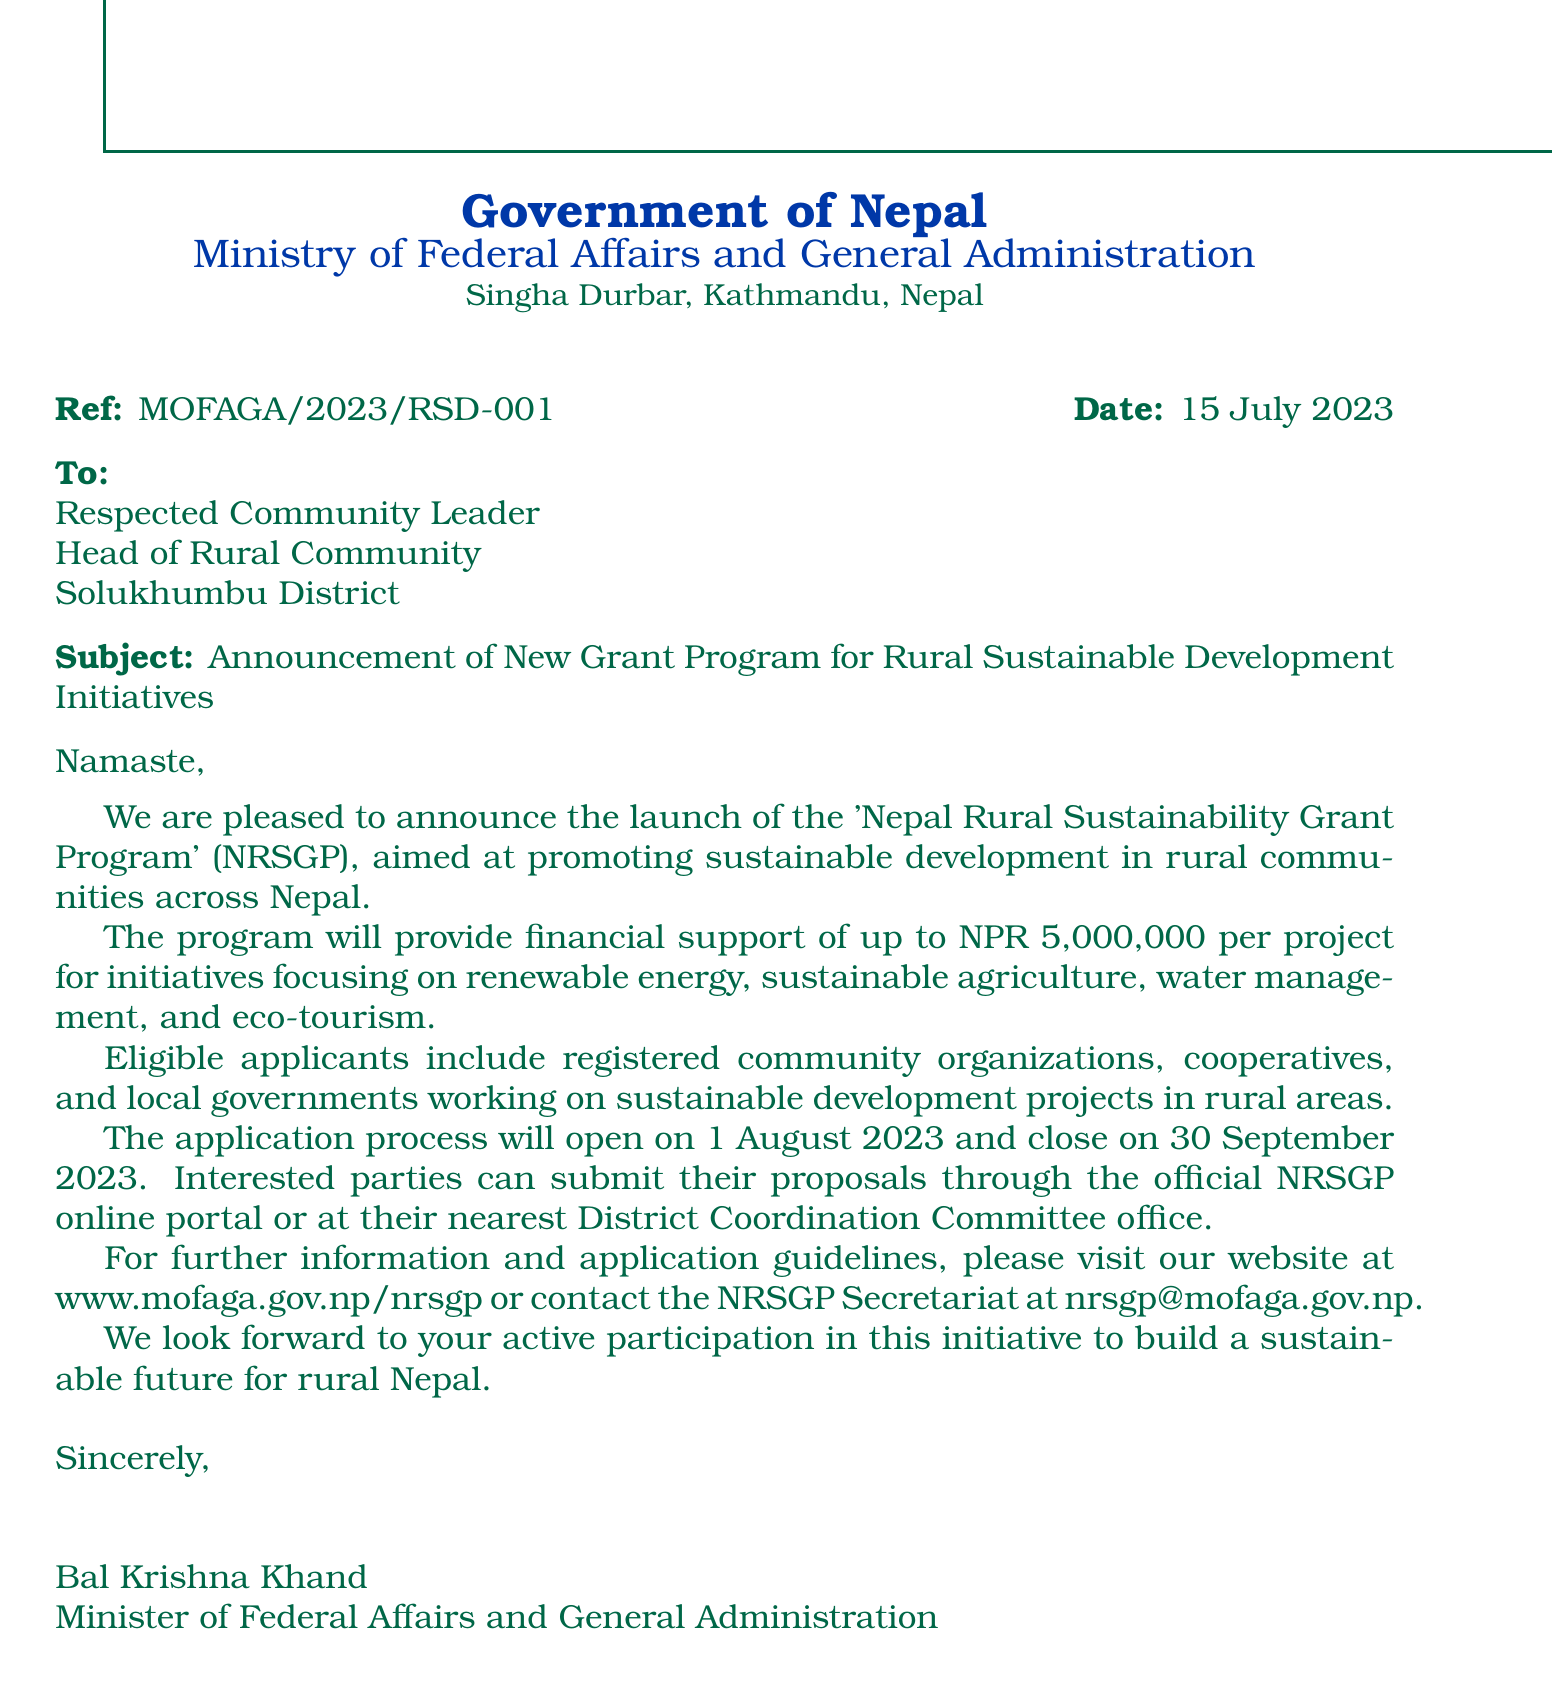what is the program name? The program name mentioned in the document is 'Nepal Rural Sustainability Grant Program' (NRSGP).
Answer: 'Nepal Rural Sustainability Grant Program' (NRSGP) what is the maximum funding amount for a project? The document states that the program will provide financial support of up to NPR 5,000,000 per project.
Answer: NPR 5,000,000 who is the sender of the letter? The sender of the letter is Bal Krishna Khand, the Minister of Federal Affairs and General Administration.
Answer: Bal Krishna Khand when does the application process open? The application process opens on 1 August 2023, as stated in the document.
Answer: 1 August 2023 who is eligible to apply for the grant? The document states that eligible applicants include registered community organizations, cooperatives, and local governments.
Answer: registered community organizations, cooperatives, and local governments what is the closing date for the applications? The closing date for the applications is 30 September 2023, according to the document.
Answer: 30 September 2023 what website can be visited for more information? The document specifies that further information can be found at www.mofaga.gov.np/nrsgp.
Answer: www.mofaga.gov.np/nrsgp what is the primary focus of the grant program? The document mentions the program focuses on initiatives related to renewable energy, sustainable agriculture, water management, and eco-tourism.
Answer: renewable energy, sustainable agriculture, water management, and eco-tourism how is the letter addressed? The letter is addressed to "Respected Community Leader, Head of Rural Community, Solukhumbu District."
Answer: Respected Community Leader, Head of Rural Community, Solukhumbu District 